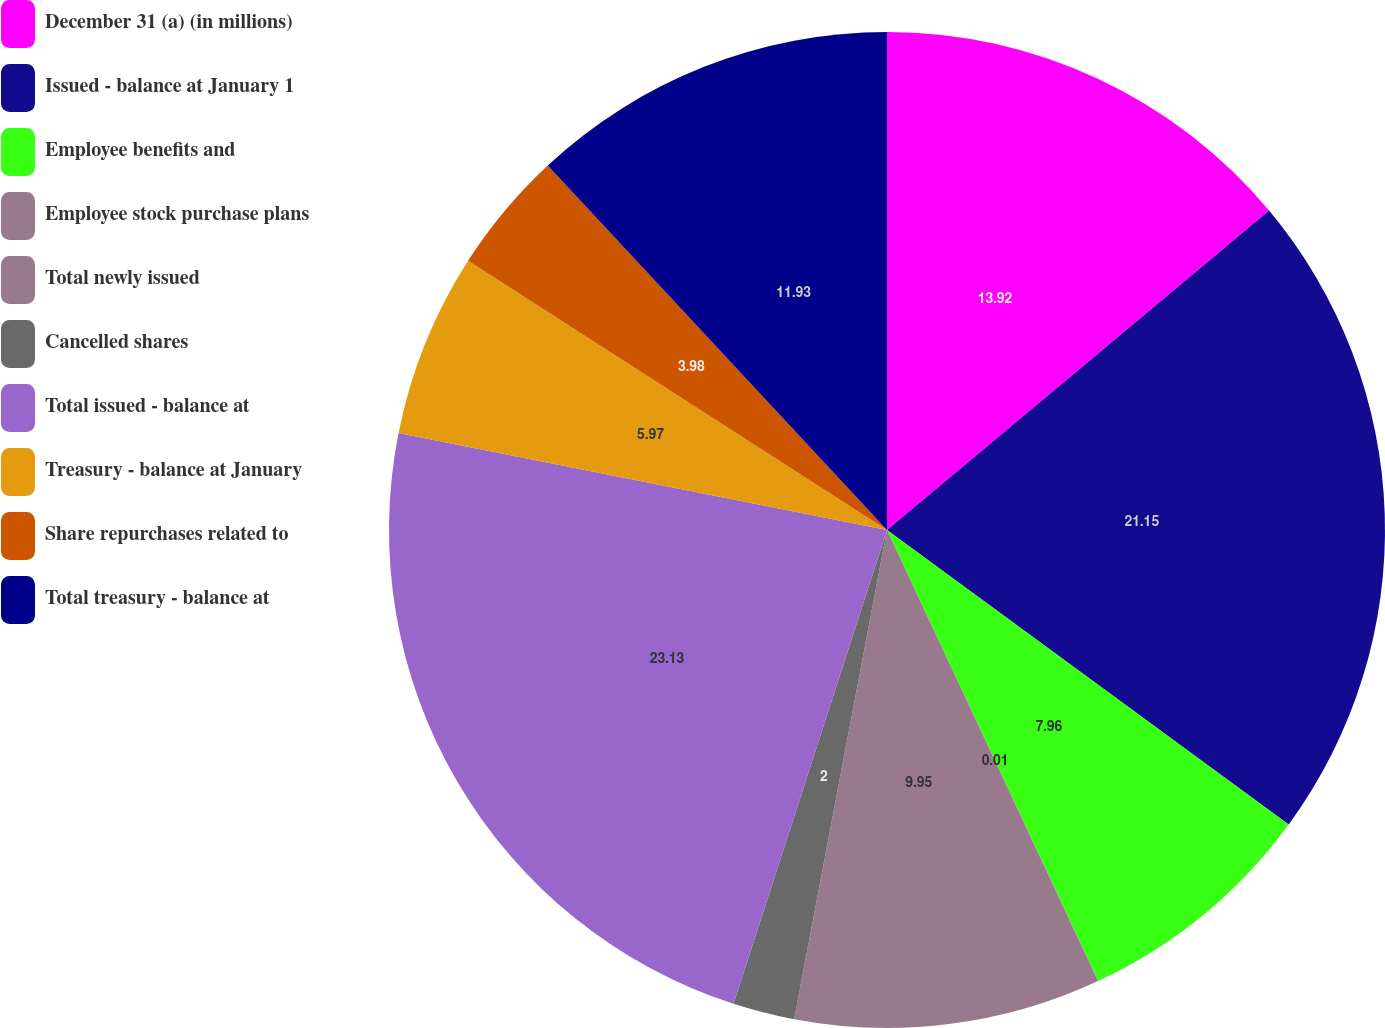<chart> <loc_0><loc_0><loc_500><loc_500><pie_chart><fcel>December 31 (a) (in millions)<fcel>Issued - balance at January 1<fcel>Employee benefits and<fcel>Employee stock purchase plans<fcel>Total newly issued<fcel>Cancelled shares<fcel>Total issued - balance at<fcel>Treasury - balance at January<fcel>Share repurchases related to<fcel>Total treasury - balance at<nl><fcel>13.92%<fcel>21.15%<fcel>7.96%<fcel>0.01%<fcel>9.95%<fcel>2.0%<fcel>23.14%<fcel>5.97%<fcel>3.98%<fcel>11.93%<nl></chart> 